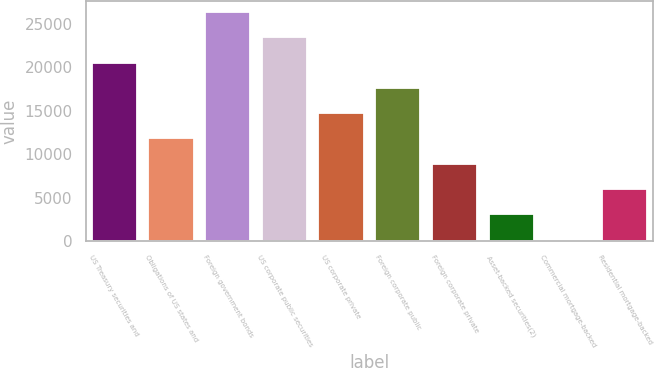<chart> <loc_0><loc_0><loc_500><loc_500><bar_chart><fcel>US Treasury securities and<fcel>Obligations of US states and<fcel>Foreign government bonds<fcel>US corporate public securities<fcel>US corporate private<fcel>Foreign corporate public<fcel>Foreign corporate private<fcel>Asset-backed securities(2)<fcel>Commercial mortgage-backed<fcel>Residential mortgage-backed<nl><fcel>20526.5<fcel>11813<fcel>26335.5<fcel>23431<fcel>14717.5<fcel>17622<fcel>8908.5<fcel>3099.5<fcel>195<fcel>6004<nl></chart> 